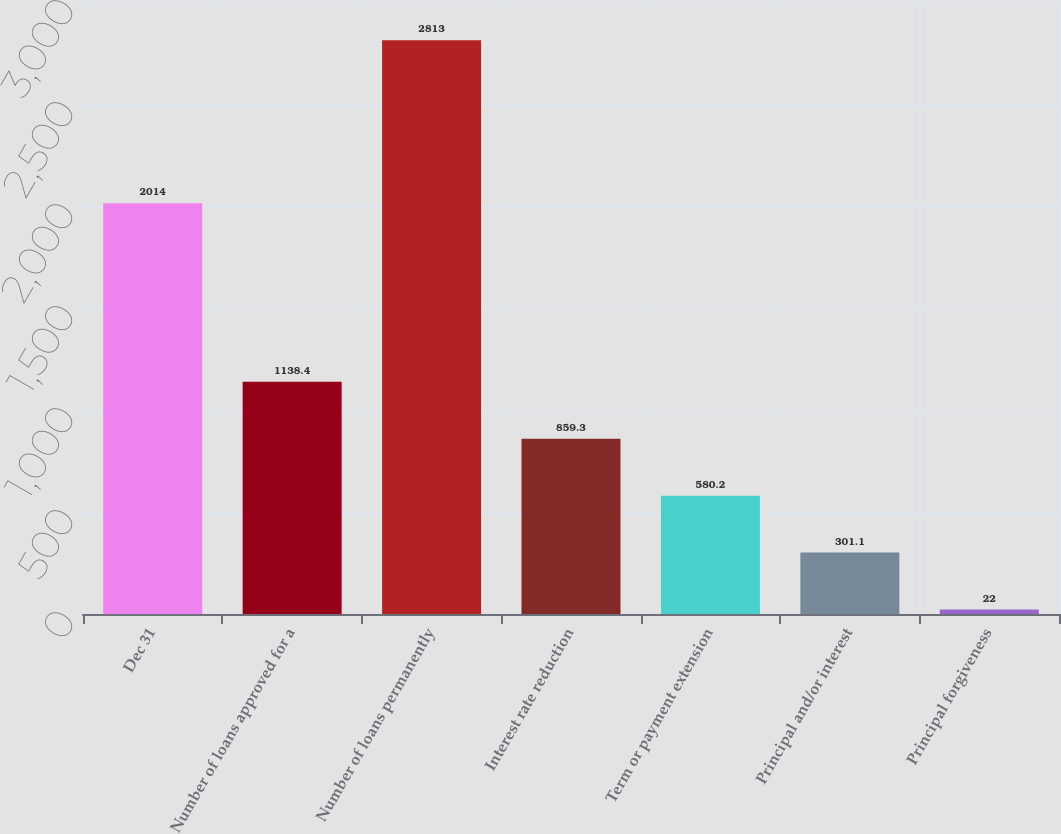Convert chart. <chart><loc_0><loc_0><loc_500><loc_500><bar_chart><fcel>Dec 31<fcel>Number of loans approved for a<fcel>Number of loans permanently<fcel>Interest rate reduction<fcel>Term or payment extension<fcel>Principal and/or interest<fcel>Principal forgiveness<nl><fcel>2014<fcel>1138.4<fcel>2813<fcel>859.3<fcel>580.2<fcel>301.1<fcel>22<nl></chart> 